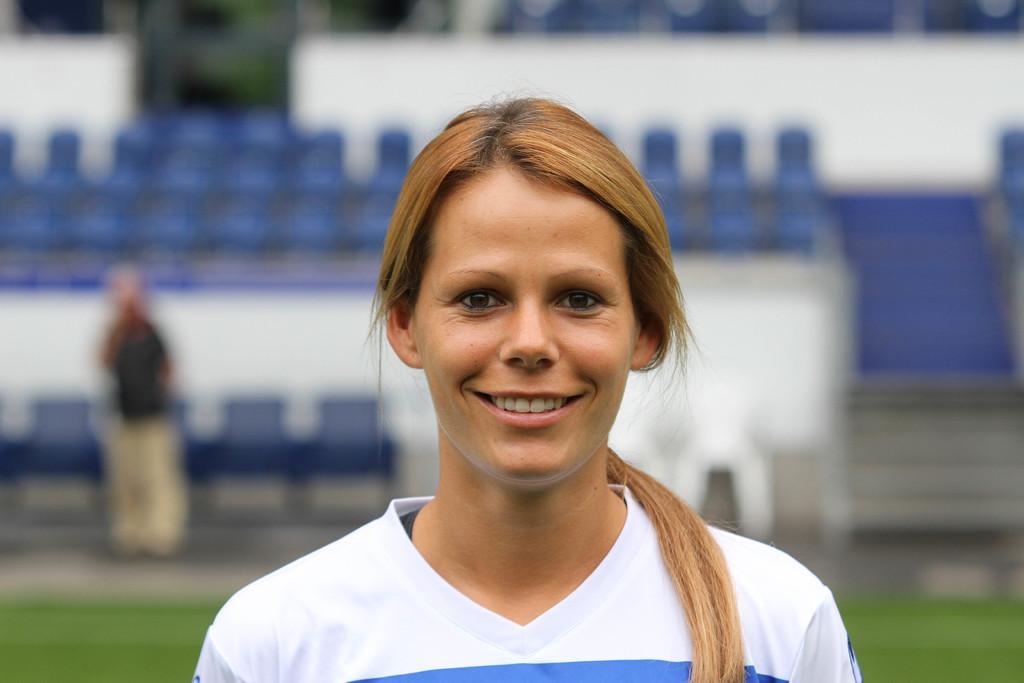Can you describe this image briefly? This picture shows few woman standing with a smile on her face and we see few chairs and a person standing on the back and we see grass on the ground. 